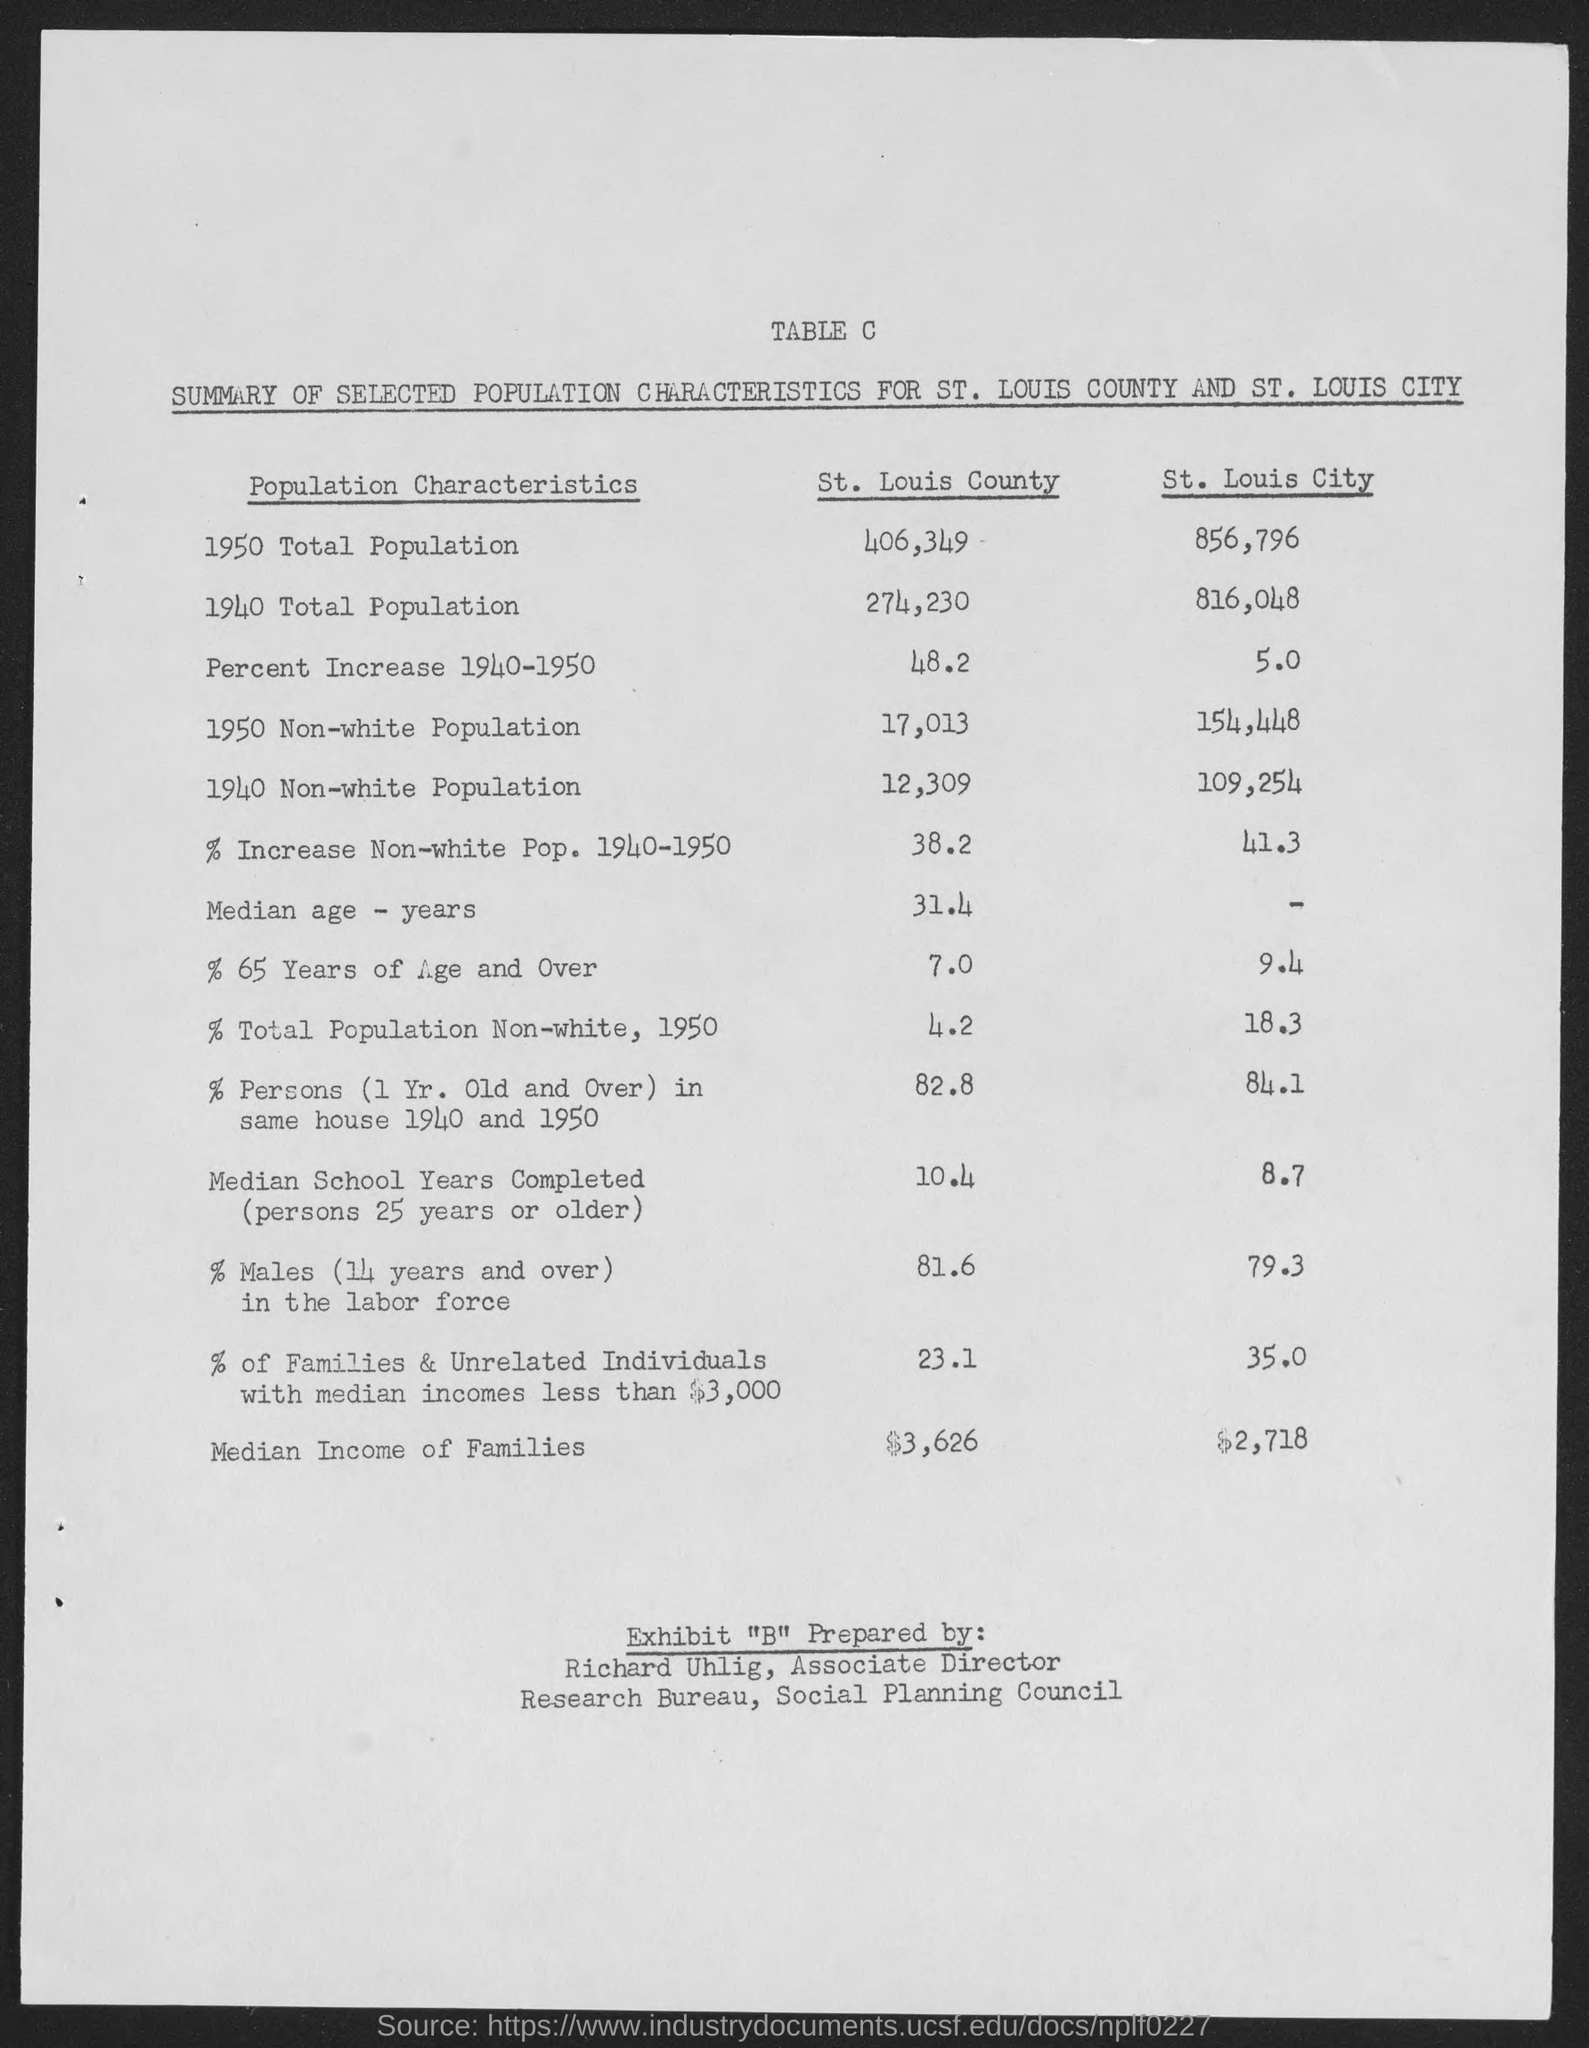Highlight a few significant elements in this photo. The non-white population of St. Louis County in the year 1950 was 17,013. The median income of families in St. Louis county is $3,626. The total population of St. Louis City in 1940 was 816,048. In 1950, the total population of St. Louis County was 406,349 individuals. The median income of families in St. Louis city is $2,718. 